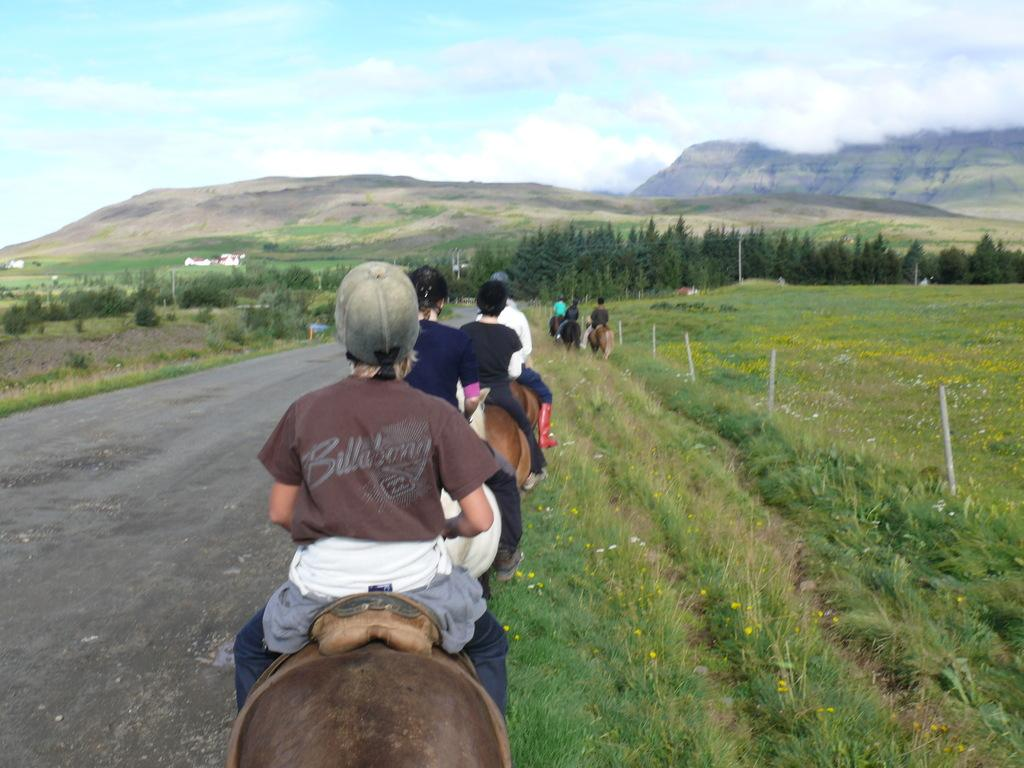What are the people in the image doing? The people in the image are sitting on animals. What can be seen on the left side of the image? There is a road on the left side of the image. What is visible in the background of the image? There are trees and hills in the background of the image. What type of zephyr can be seen blowing through the image? There is no zephyr present in the image; it is a term used to describe a gentle breeze, and there is no indication of wind in the image. 